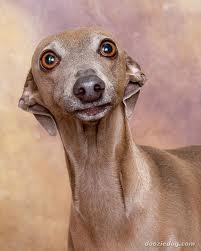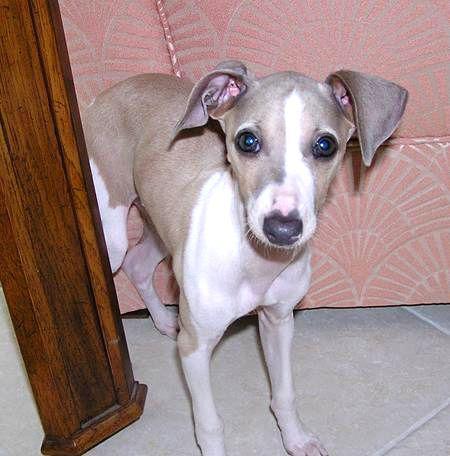The first image is the image on the left, the second image is the image on the right. Examine the images to the left and right. Is the description "The dog in one of the images is sitting on a soft surface." accurate? Answer yes or no. No. The first image is the image on the left, the second image is the image on the right. For the images displayed, is the sentence "In one image, a dog's very long tongue is outside of its mouth and at least one ear is pulled towards the back of its head." factually correct? Answer yes or no. No. 